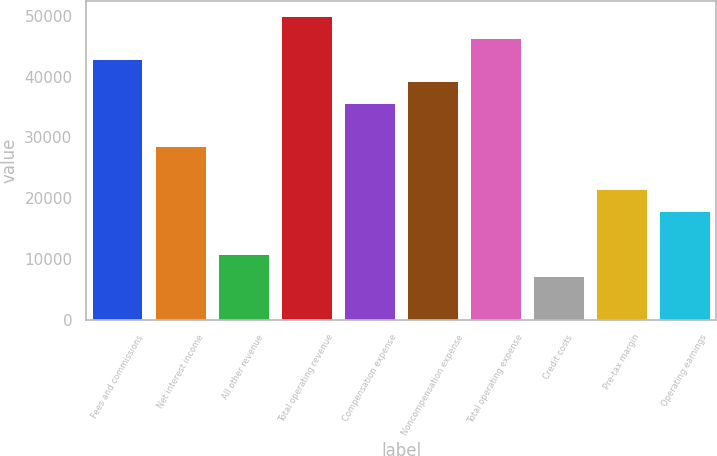Convert chart. <chart><loc_0><loc_0><loc_500><loc_500><bar_chart><fcel>Fees and commissions<fcel>Net interest income<fcel>All other revenue<fcel>Total operating revenue<fcel>Compensation expense<fcel>Noncompensation expense<fcel>Total operating expense<fcel>Credit costs<fcel>Pre-tax margin<fcel>Operating earnings<nl><fcel>42858.2<fcel>28599.8<fcel>10776.8<fcel>49987.4<fcel>35729<fcel>39293.6<fcel>46422.8<fcel>7212.2<fcel>21470.6<fcel>17906<nl></chart> 